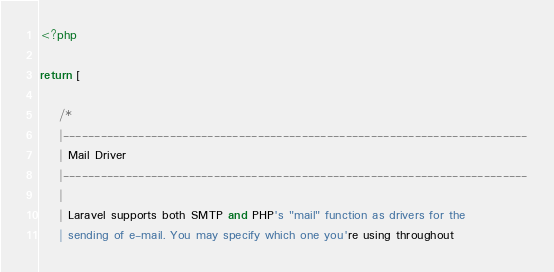Convert code to text. <code><loc_0><loc_0><loc_500><loc_500><_PHP_><?php

return [

    /*
    |--------------------------------------------------------------------------
    | Mail Driver
    |--------------------------------------------------------------------------
    |
    | Laravel supports both SMTP and PHP's "mail" function as drivers for the
    | sending of e-mail. You may specify which one you're using throughout</code> 